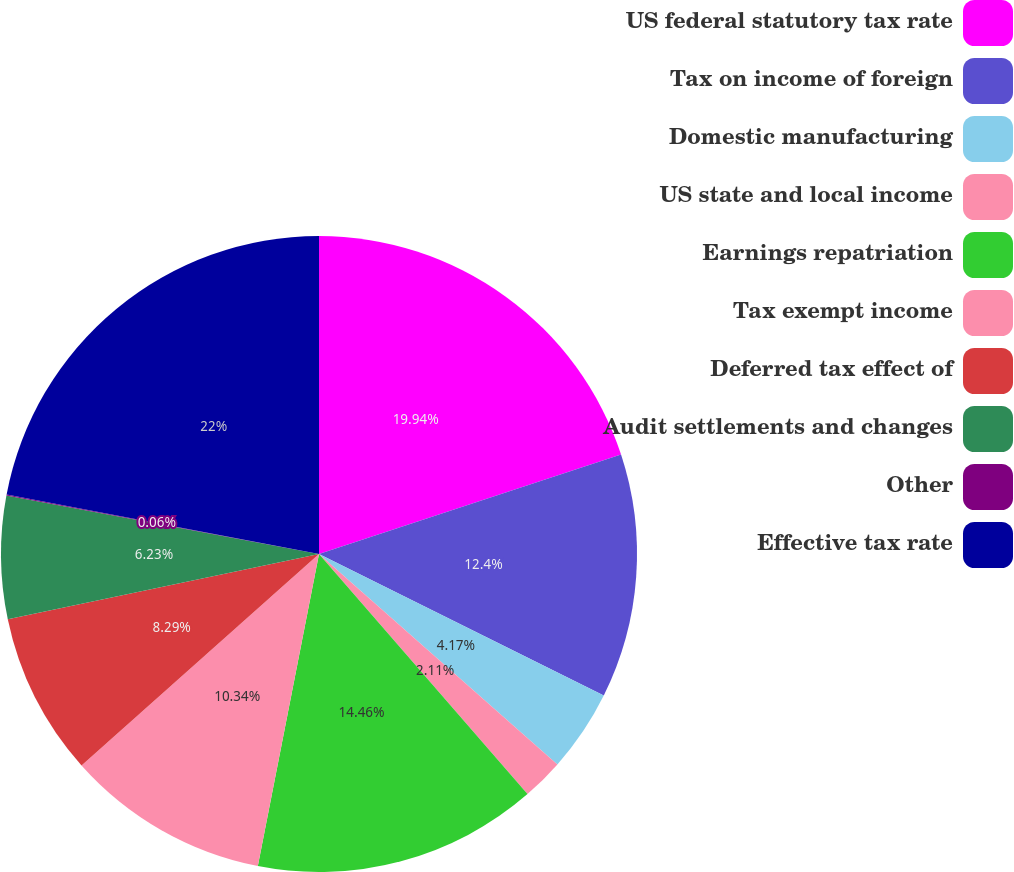Convert chart. <chart><loc_0><loc_0><loc_500><loc_500><pie_chart><fcel>US federal statutory tax rate<fcel>Tax on income of foreign<fcel>Domestic manufacturing<fcel>US state and local income<fcel>Earnings repatriation<fcel>Tax exempt income<fcel>Deferred tax effect of<fcel>Audit settlements and changes<fcel>Other<fcel>Effective tax rate<nl><fcel>19.94%<fcel>12.4%<fcel>4.17%<fcel>2.11%<fcel>14.46%<fcel>10.34%<fcel>8.29%<fcel>6.23%<fcel>0.06%<fcel>22.0%<nl></chart> 